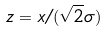<formula> <loc_0><loc_0><loc_500><loc_500>z = x / ( \sqrt { 2 } \sigma )</formula> 